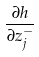Convert formula to latex. <formula><loc_0><loc_0><loc_500><loc_500>\frac { \partial h } { \partial z _ { j } ^ { - } }</formula> 